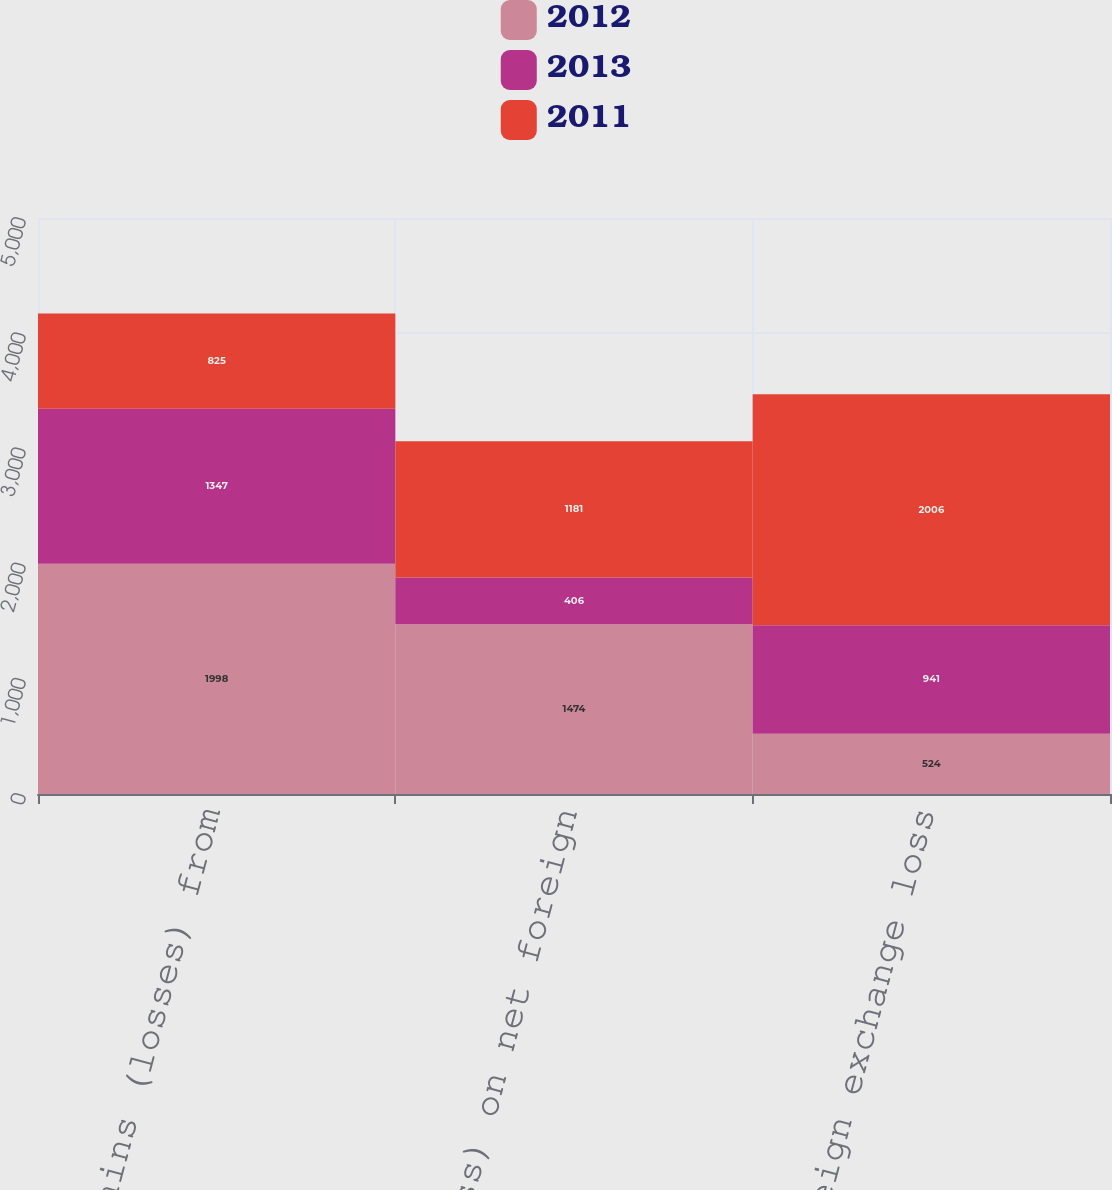<chart> <loc_0><loc_0><loc_500><loc_500><stacked_bar_chart><ecel><fcel>Change in gains (losses) from<fcel>Gain (loss) on net foreign<fcel>Net foreign exchange loss<nl><fcel>2012<fcel>1998<fcel>1474<fcel>524<nl><fcel>2013<fcel>1347<fcel>406<fcel>941<nl><fcel>2011<fcel>825<fcel>1181<fcel>2006<nl></chart> 